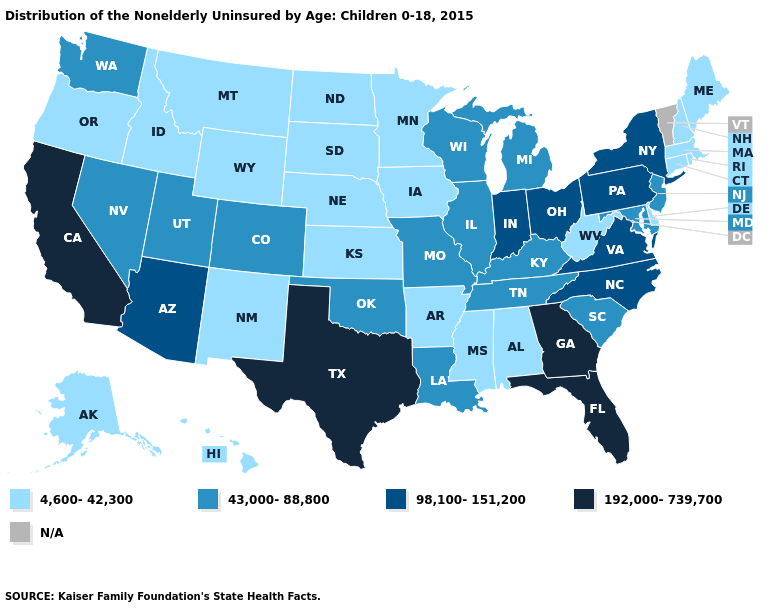What is the value of Maryland?
Give a very brief answer. 43,000-88,800. Which states have the lowest value in the South?
Keep it brief. Alabama, Arkansas, Delaware, Mississippi, West Virginia. What is the highest value in states that border Oklahoma?
Concise answer only. 192,000-739,700. Which states have the lowest value in the Northeast?
Keep it brief. Connecticut, Maine, Massachusetts, New Hampshire, Rhode Island. What is the value of Nebraska?
Write a very short answer. 4,600-42,300. What is the lowest value in states that border Rhode Island?
Answer briefly. 4,600-42,300. Name the states that have a value in the range 192,000-739,700?
Give a very brief answer. California, Florida, Georgia, Texas. Name the states that have a value in the range N/A?
Short answer required. Vermont. What is the value of South Dakota?
Short answer required. 4,600-42,300. Name the states that have a value in the range 98,100-151,200?
Quick response, please. Arizona, Indiana, New York, North Carolina, Ohio, Pennsylvania, Virginia. Does Massachusetts have the lowest value in the Northeast?
Short answer required. Yes. Does California have the highest value in the USA?
Answer briefly. Yes. Does the first symbol in the legend represent the smallest category?
Concise answer only. Yes. 